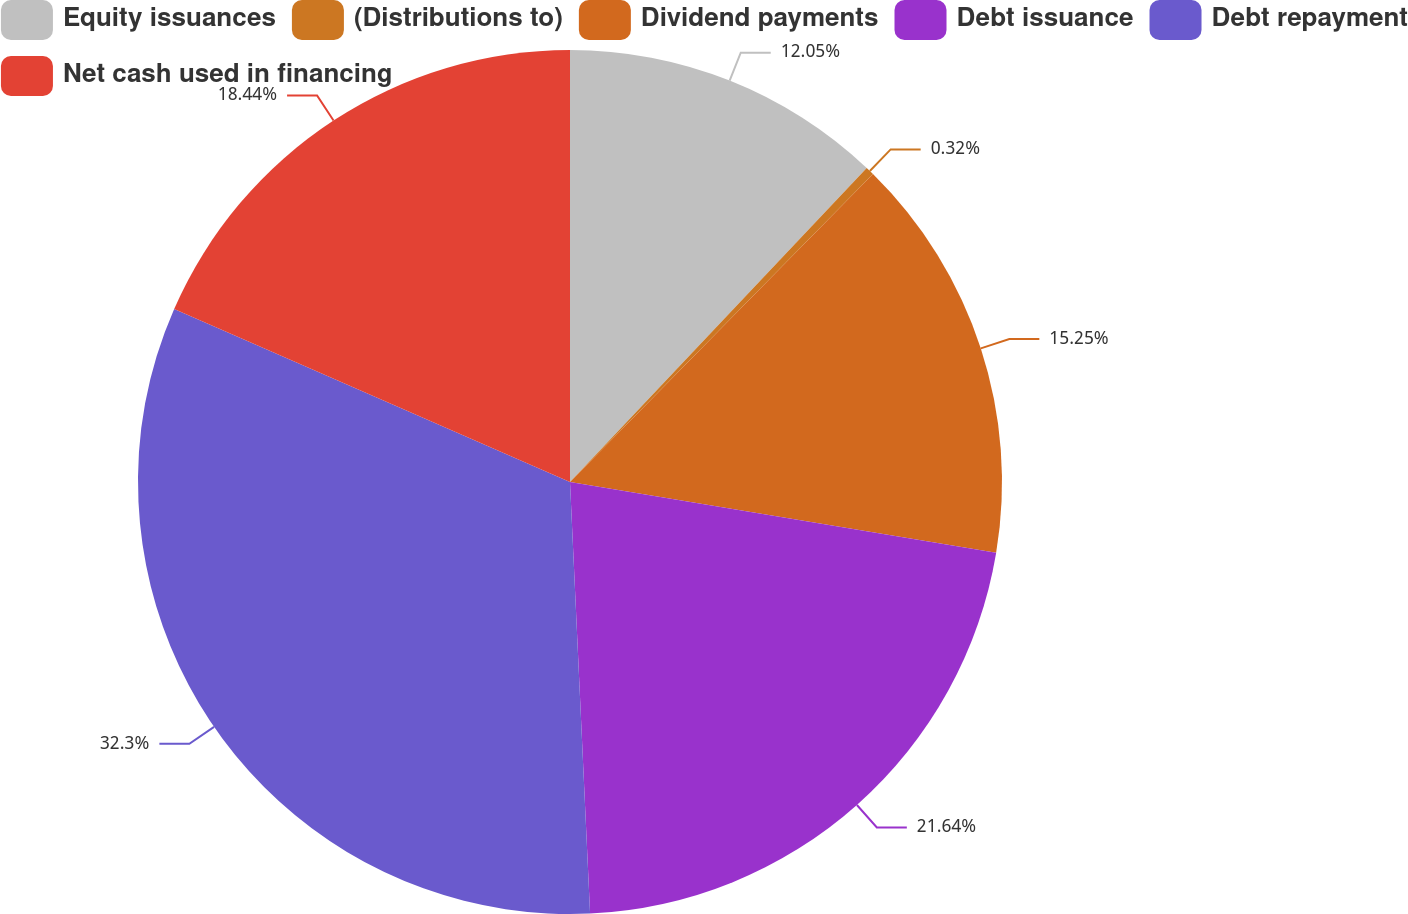<chart> <loc_0><loc_0><loc_500><loc_500><pie_chart><fcel>Equity issuances<fcel>(Distributions to)<fcel>Dividend payments<fcel>Debt issuance<fcel>Debt repayment<fcel>Net cash used in financing<nl><fcel>12.05%<fcel>0.32%<fcel>15.25%<fcel>21.64%<fcel>32.3%<fcel>18.44%<nl></chart> 